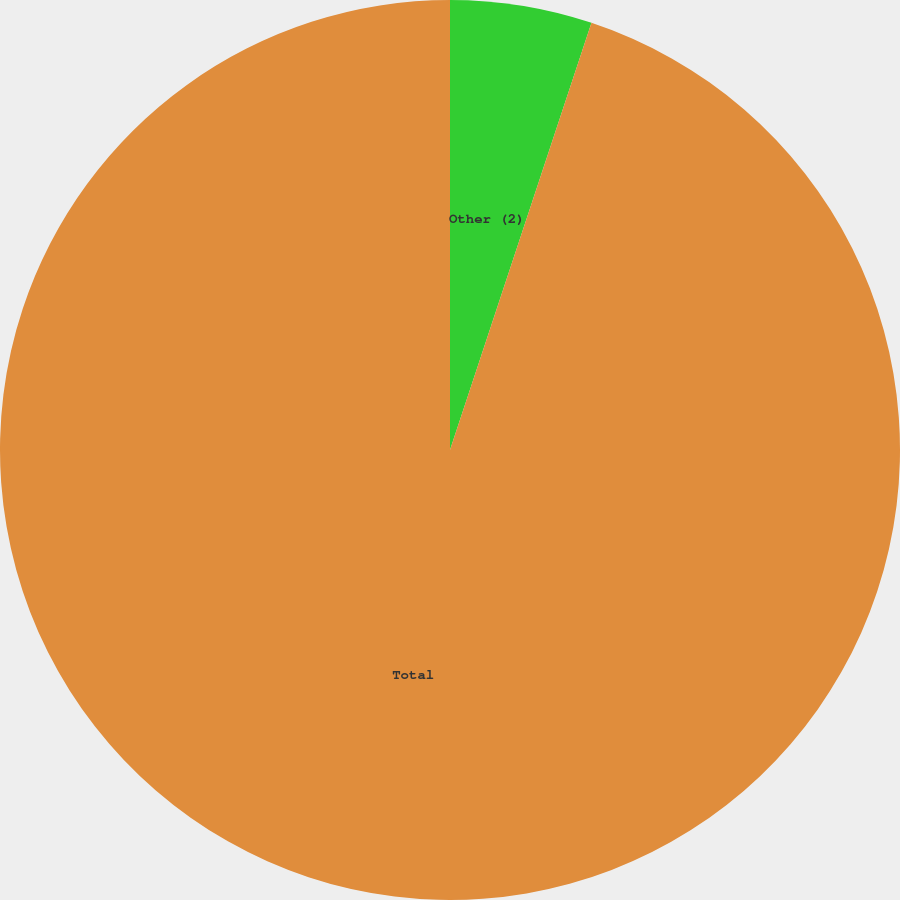Convert chart to OTSL. <chart><loc_0><loc_0><loc_500><loc_500><pie_chart><fcel>Other (2)<fcel>Total<nl><fcel>5.09%<fcel>94.91%<nl></chart> 